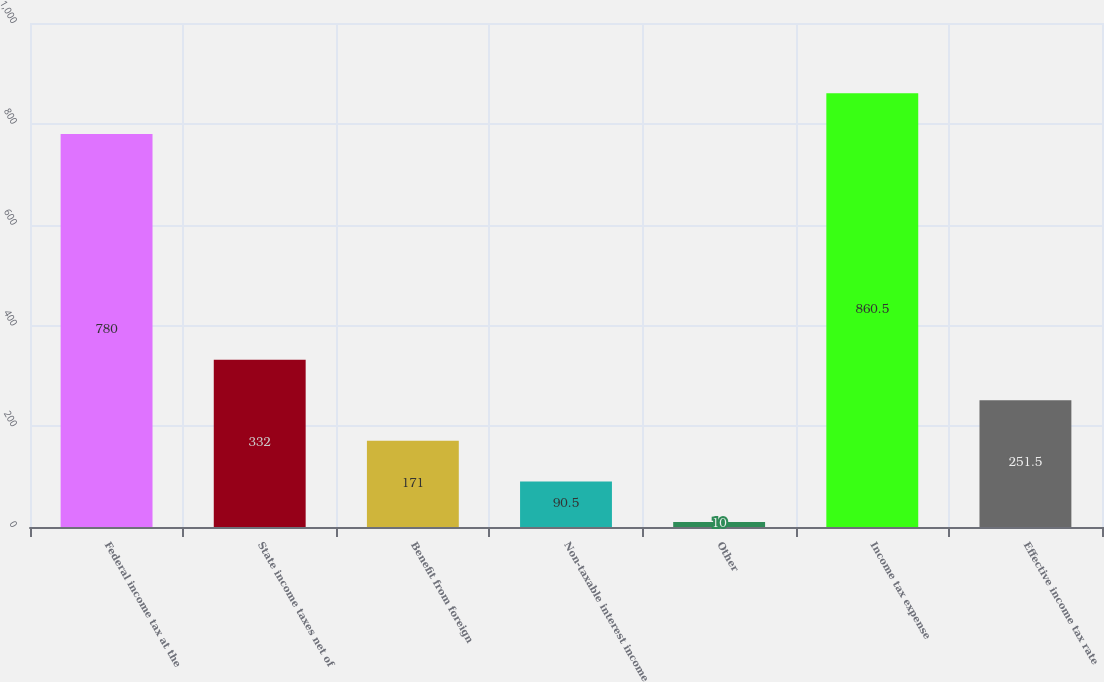<chart> <loc_0><loc_0><loc_500><loc_500><bar_chart><fcel>Federal income tax at the<fcel>State income taxes net of<fcel>Benefit from foreign<fcel>Non-taxable interest income<fcel>Other<fcel>Income tax expense<fcel>Effective income tax rate<nl><fcel>780<fcel>332<fcel>171<fcel>90.5<fcel>10<fcel>860.5<fcel>251.5<nl></chart> 